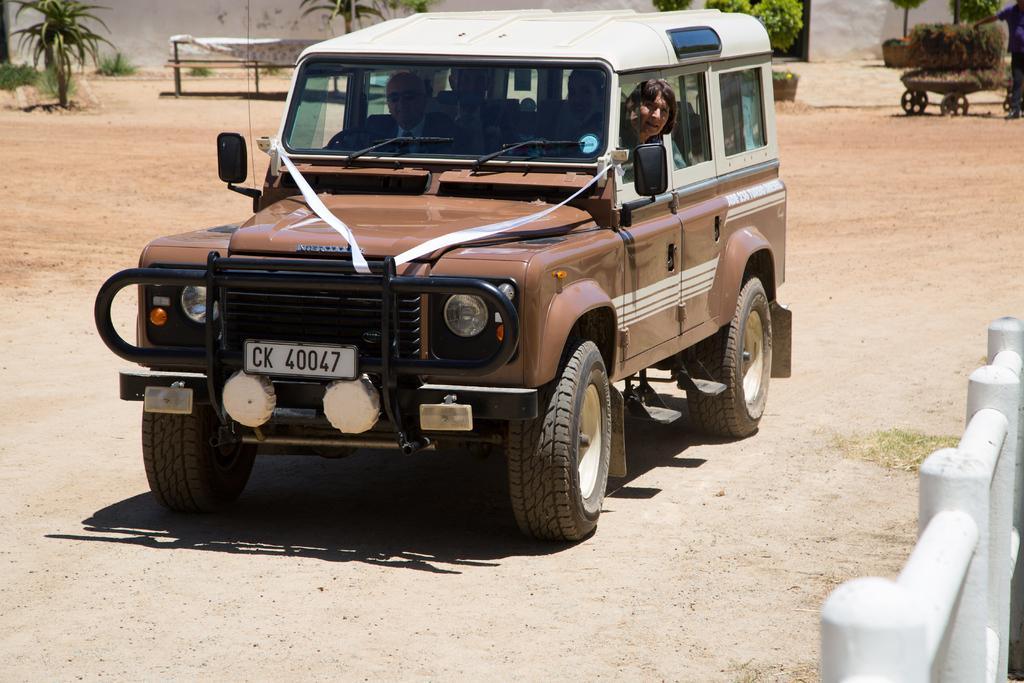Describe this image in one or two sentences. I the middle of the picture there is a jeep on the road. Inside the jeep there are four people sitting. A man is sitting and he is driving. And there is a lady seeing outside from the window. And to the right bottom of the corner there is a fencing. And to the right bottom corner there is a man holding a stroller. And there are some plants. And to the top left corner there is a tree. Beside the tree there is a cloth on the rods. 